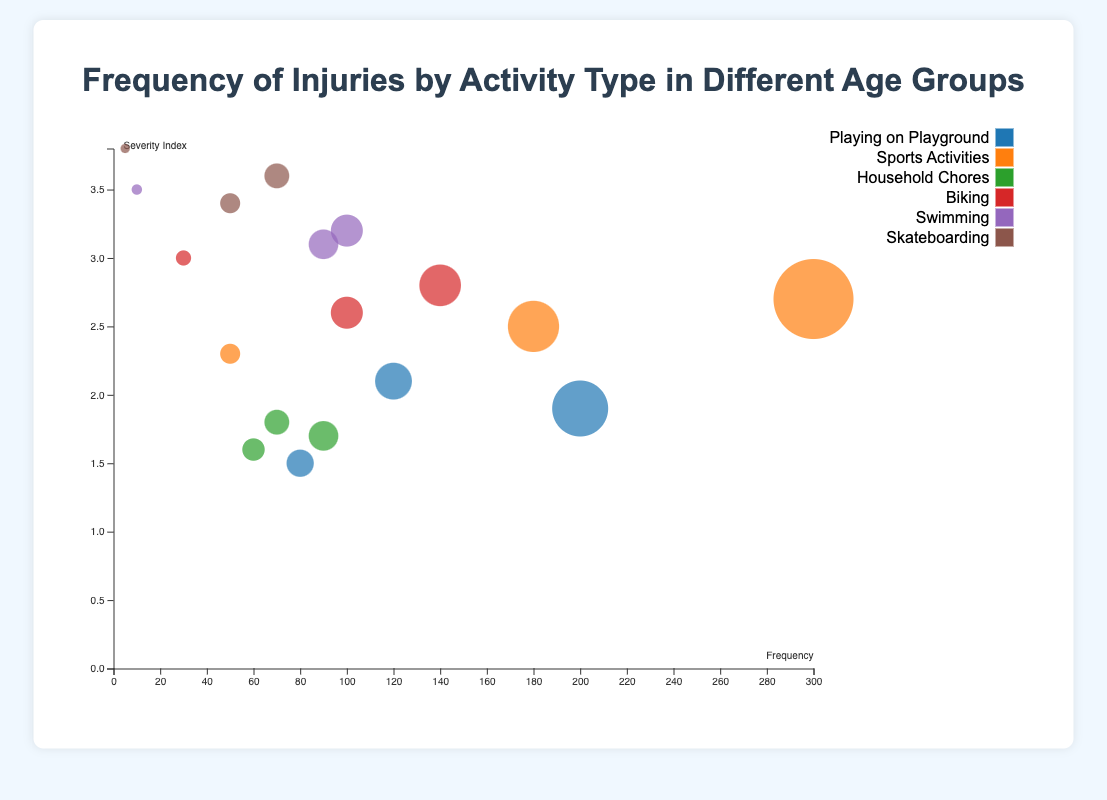What activity has the highest frequency of injuries for the 13-18 age group? Observing the largest circle in the age group 13-18, we see that "Sports Activities" have the highest frequency with 300 injuries.
Answer: Sports Activities Which age group has the highest severity index for swimming-related injuries? By looking at the y-axis and the positions of the bubbles for "Swimming", the age group 0-5 has the highest severity index at 3.5.
Answer: 0-5 What is the frequency of injuries for children aged 6-12 when biking? The bubble for biking in the age group 6-12 shows that the frequency is 140.
Answer: 140 Which age group experiences the lowest frequency of injuries when skateboarding? The smallest bubble for "Skateboarding" is in the age group 0-5 with a frequency of 5.
Answer: 0-5 Compare the severity index of playground injuries between the age groups 0-5 and 6-12. Which is higher? The severity index for playground injuries for age group 0-5 is 2.1, while for age group 6-12, it is 1.9. Therefore, the severity is higher for the 0-5 age group.
Answer: 0-5 What is the median severity index for all age groups combined for the activity "Sports Activities"? The severity indices for "Sports Activities" are 2.3 (0-5), 2.5 (6-12), and 2.7 (13-18). The median is the middle value, which is 2.5.
Answer: 2.5 How does the frequency of biking injuries compare between the age groups 0-5 and 6-12? The frequency of biking injuries for the 0-5 age group is 30, while for the 6-12 age group, it is 140. Therefore, the 6-12 age group has significantly higher biking injuries.
Answer: 6-12 Identify the lowest severity index recorded in any activity for any age group. The lowest severity index across all activities and age groups is 1.5 for "Playing on Playground" in the age group 13-18.
Answer: 1.5 What is the total frequency of injuries for "Household Chores" across all age groups? The frequencies are 70 (0-5), 90 (6-12), and 60 (13-18). Summing these values gives 70 + 90 + 60 = 220.
Answer: 220 